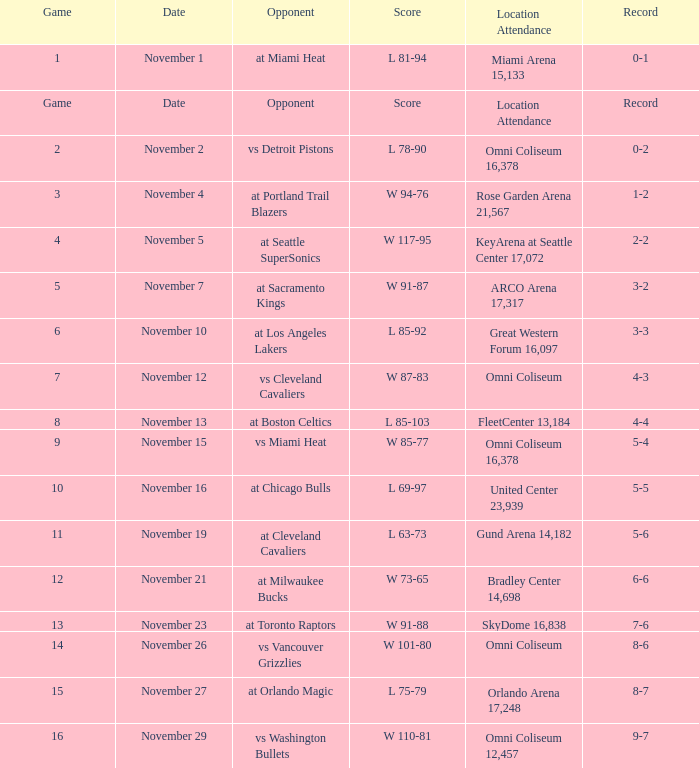On which date was game 3? November 4. 